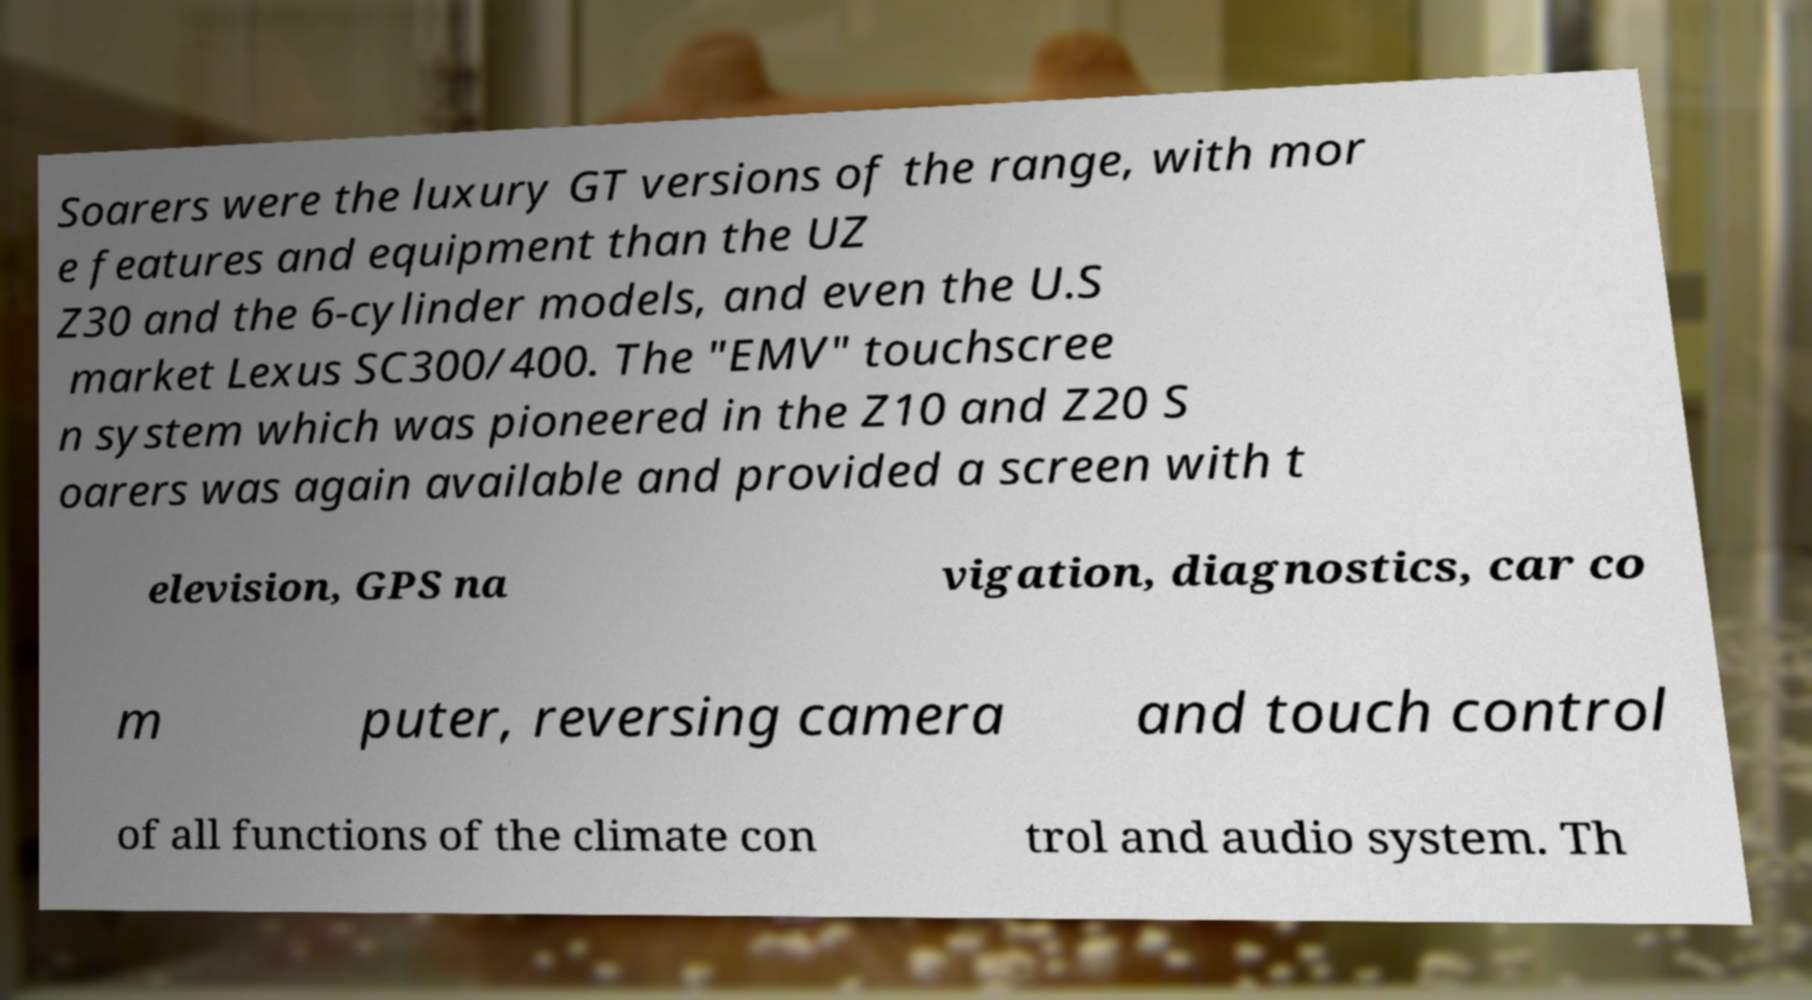There's text embedded in this image that I need extracted. Can you transcribe it verbatim? Soarers were the luxury GT versions of the range, with mor e features and equipment than the UZ Z30 and the 6-cylinder models, and even the U.S market Lexus SC300/400. The "EMV" touchscree n system which was pioneered in the Z10 and Z20 S oarers was again available and provided a screen with t elevision, GPS na vigation, diagnostics, car co m puter, reversing camera and touch control of all functions of the climate con trol and audio system. Th 